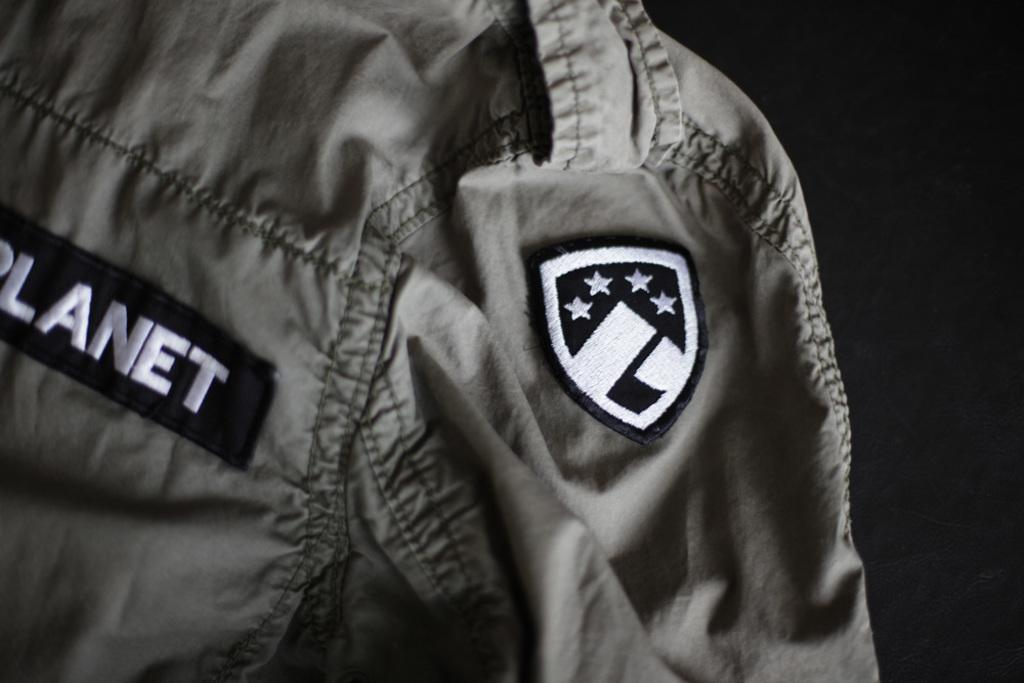<image>
Write a terse but informative summary of the picture. Someone wears a uniform that says, "Planet" on it. 